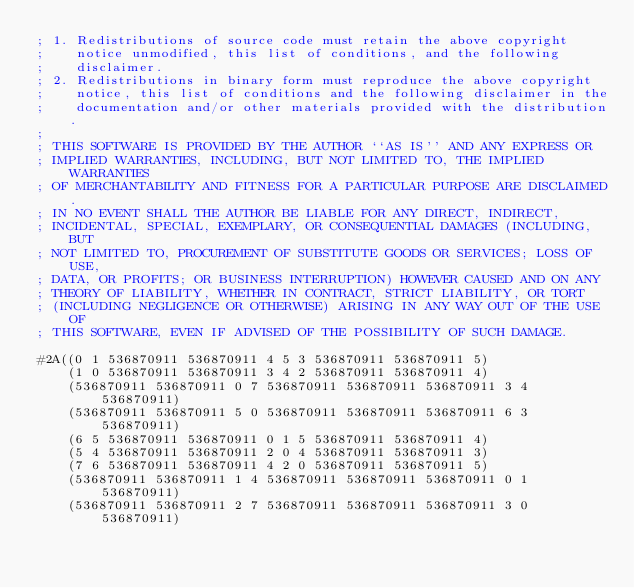Convert code to text. <code><loc_0><loc_0><loc_500><loc_500><_Lisp_>; 1. Redistributions of source code must retain the above copyright
;    notice unmodified, this list of conditions, and the following
;    disclaimer.
; 2. Redistributions in binary form must reproduce the above copyright
;    notice, this list of conditions and the following disclaimer in the
;    documentation and/or other materials provided with the distribution.
;
; THIS SOFTWARE IS PROVIDED BY THE AUTHOR ``AS IS'' AND ANY EXPRESS OR
; IMPLIED WARRANTIES, INCLUDING, BUT NOT LIMITED TO, THE IMPLIED WARRANTIES
; OF MERCHANTABILITY AND FITNESS FOR A PARTICULAR PURPOSE ARE DISCLAIMED.
; IN NO EVENT SHALL THE AUTHOR BE LIABLE FOR ANY DIRECT, INDIRECT,
; INCIDENTAL, SPECIAL, EXEMPLARY, OR CONSEQUENTIAL DAMAGES (INCLUDING, BUT
; NOT LIMITED TO, PROCUREMENT OF SUBSTITUTE GOODS OR SERVICES; LOSS OF USE,
; DATA, OR PROFITS; OR BUSINESS INTERRUPTION) HOWEVER CAUSED AND ON ANY
; THEORY OF LIABILITY, WHETHER IN CONTRACT, STRICT LIABILITY, OR TORT
; (INCLUDING NEGLIGENCE OR OTHERWISE) ARISING IN ANY WAY OUT OF THE USE OF
; THIS SOFTWARE, EVEN IF ADVISED OF THE POSSIBILITY OF SUCH DAMAGE.

#2A((0 1 536870911 536870911 4 5 3 536870911 536870911 5)
    (1 0 536870911 536870911 3 4 2 536870911 536870911 4)
    (536870911 536870911 0 7 536870911 536870911 536870911 3 4 536870911)
    (536870911 536870911 5 0 536870911 536870911 536870911 6 3 536870911)
    (6 5 536870911 536870911 0 1 5 536870911 536870911 4)
    (5 4 536870911 536870911 2 0 4 536870911 536870911 3)
    (7 6 536870911 536870911 4 2 0 536870911 536870911 5)
    (536870911 536870911 1 4 536870911 536870911 536870911 0 1 536870911)
    (536870911 536870911 2 7 536870911 536870911 536870911 3 0 536870911)</code> 